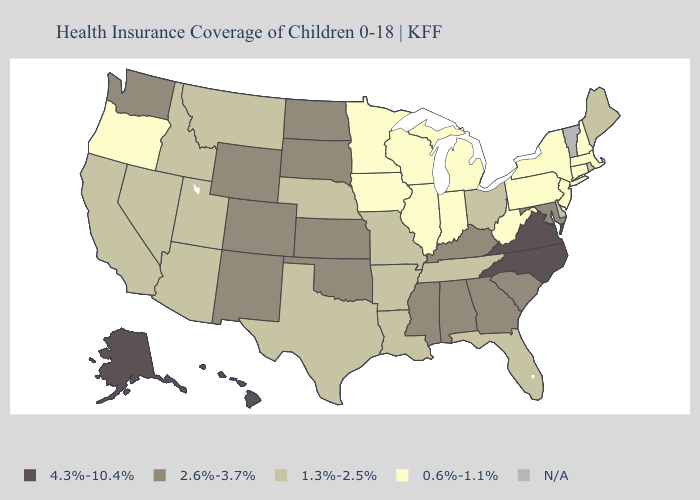Among the states that border Illinois , which have the lowest value?
Be succinct. Indiana, Iowa, Wisconsin. What is the value of Washington?
Quick response, please. 2.6%-3.7%. What is the value of West Virginia?
Answer briefly. 0.6%-1.1%. Does the first symbol in the legend represent the smallest category?
Answer briefly. No. Does North Carolina have the highest value in the USA?
Short answer required. Yes. Name the states that have a value in the range 1.3%-2.5%?
Answer briefly. Arizona, Arkansas, California, Delaware, Florida, Idaho, Louisiana, Maine, Missouri, Montana, Nebraska, Nevada, Ohio, Rhode Island, Tennessee, Texas, Utah. Name the states that have a value in the range 4.3%-10.4%?
Write a very short answer. Alaska, Hawaii, North Carolina, Virginia. What is the value of Idaho?
Give a very brief answer. 1.3%-2.5%. What is the highest value in the Northeast ?
Write a very short answer. 1.3%-2.5%. Does the map have missing data?
Write a very short answer. Yes. Name the states that have a value in the range 2.6%-3.7%?
Quick response, please. Alabama, Colorado, Georgia, Kansas, Kentucky, Maryland, Mississippi, New Mexico, North Dakota, Oklahoma, South Carolina, South Dakota, Washington, Wyoming. Name the states that have a value in the range 2.6%-3.7%?
Give a very brief answer. Alabama, Colorado, Georgia, Kansas, Kentucky, Maryland, Mississippi, New Mexico, North Dakota, Oklahoma, South Carolina, South Dakota, Washington, Wyoming. 